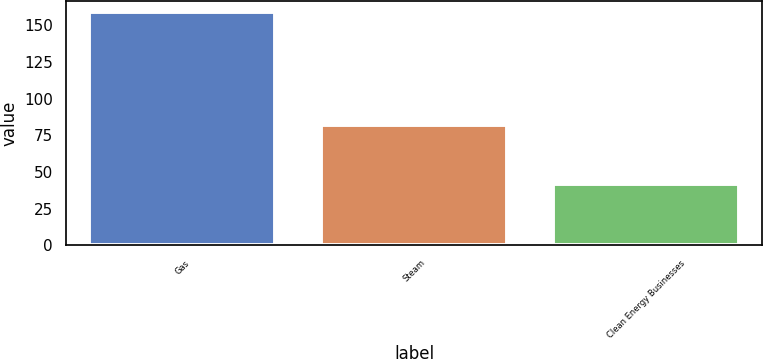Convert chart to OTSL. <chart><loc_0><loc_0><loc_500><loc_500><bar_chart><fcel>Gas<fcel>Steam<fcel>Clean Energy Businesses<nl><fcel>159<fcel>82<fcel>42<nl></chart> 